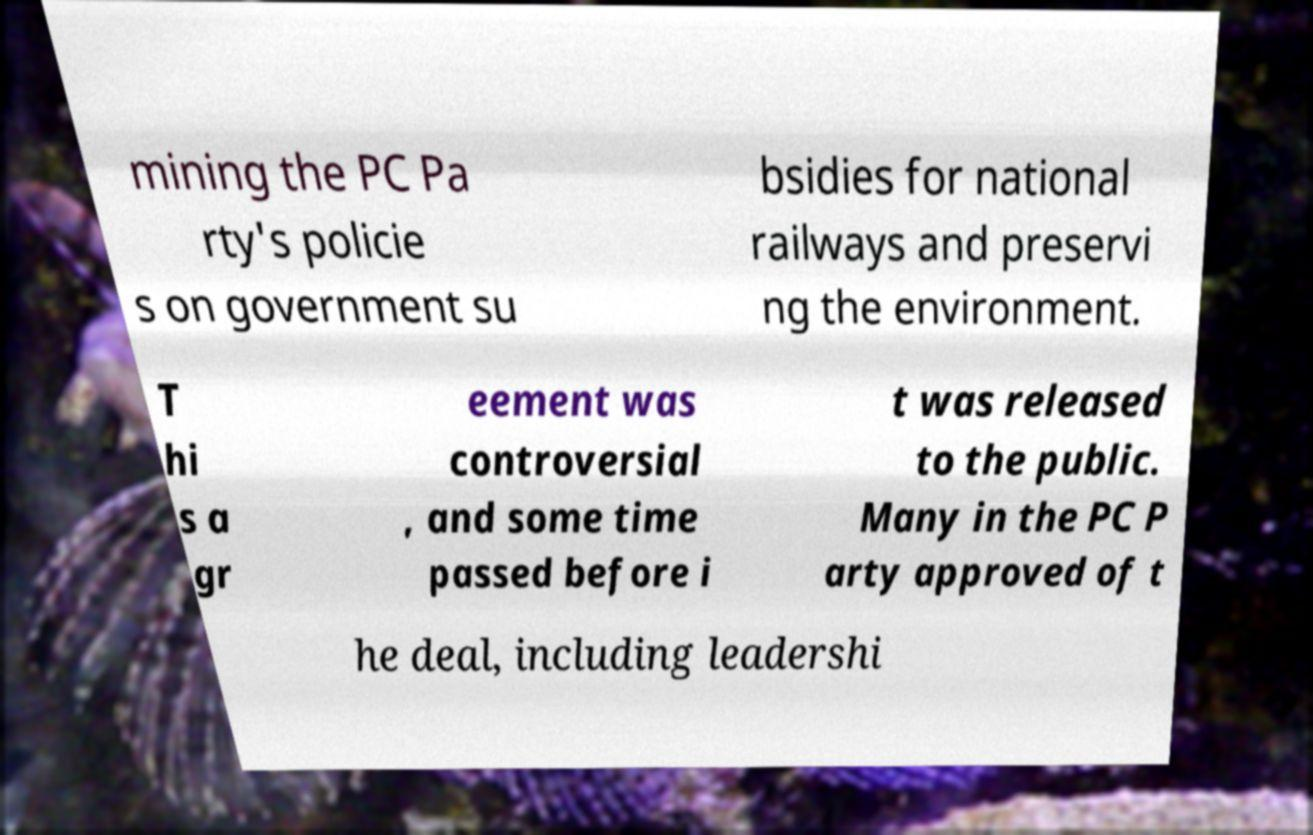Could you assist in decoding the text presented in this image and type it out clearly? mining the PC Pa rty's policie s on government su bsidies for national railways and preservi ng the environment. T hi s a gr eement was controversial , and some time passed before i t was released to the public. Many in the PC P arty approved of t he deal, including leadershi 